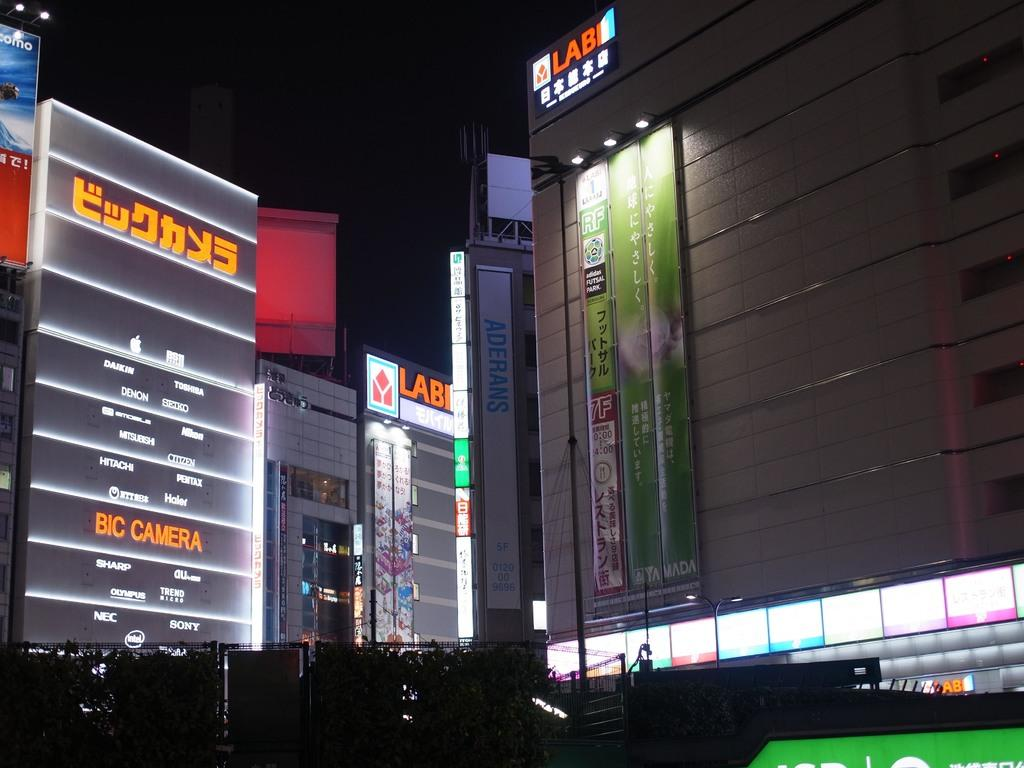<image>
Write a terse but informative summary of the picture. Building with orange word saying "LAB" on a clear night. 